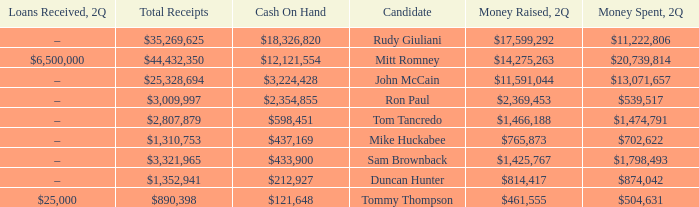Name the money raised when 2Q has money spent and 2Q is $874,042 $814,417. 